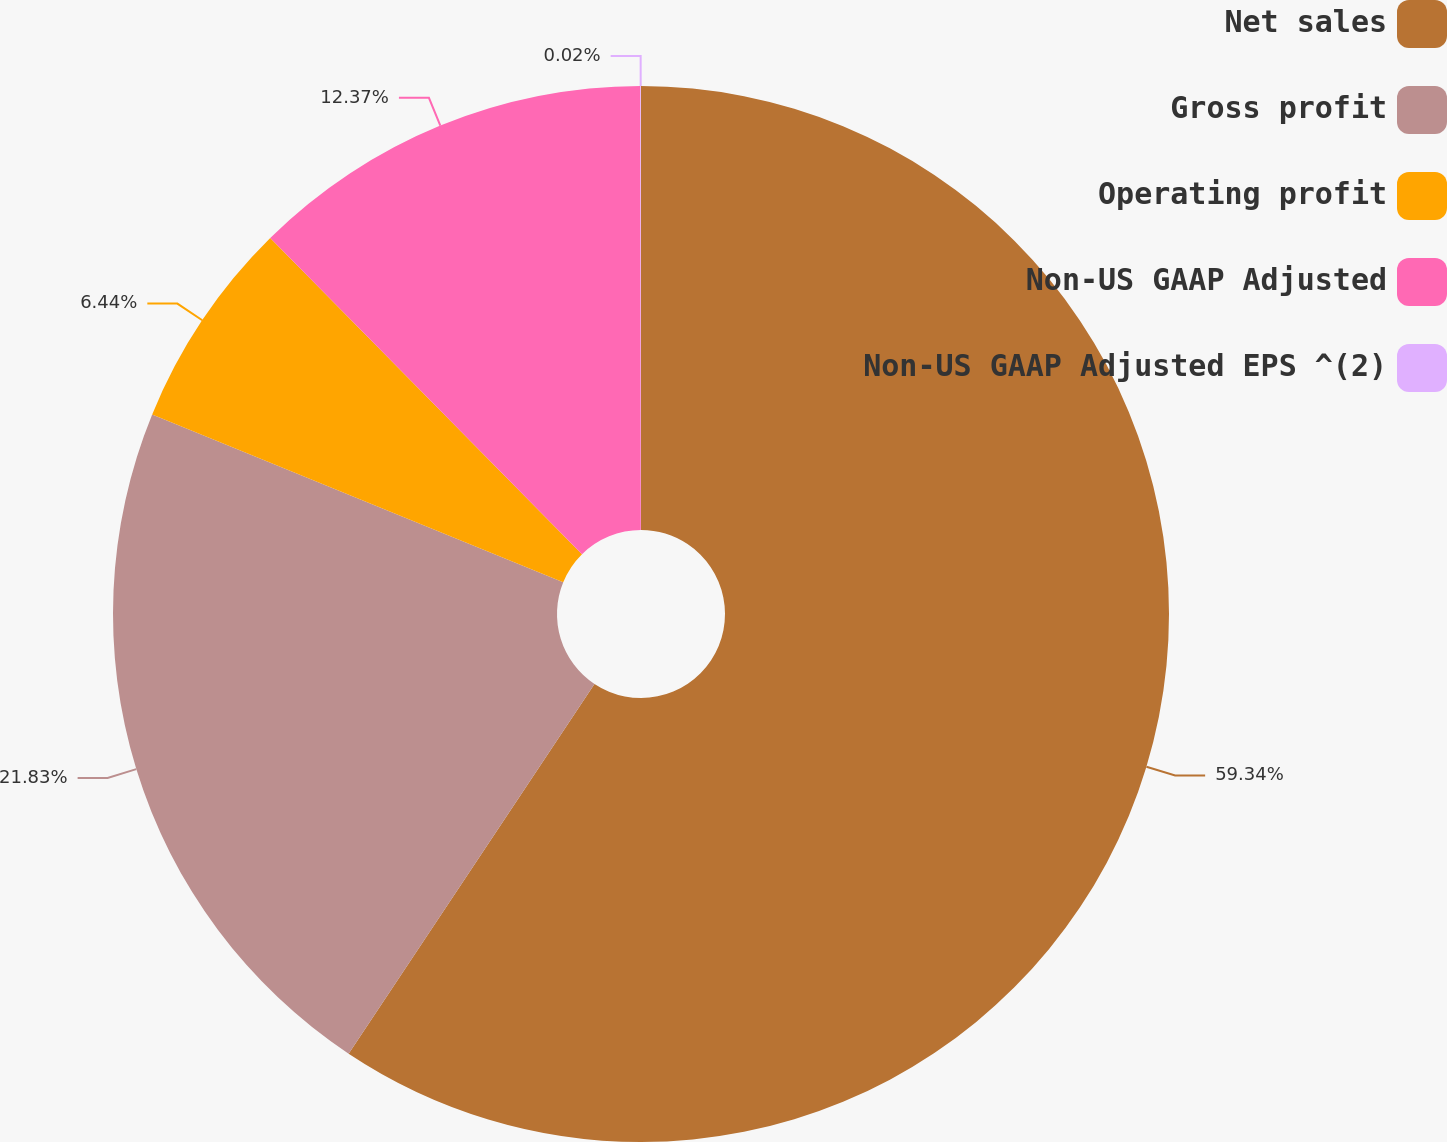Convert chart to OTSL. <chart><loc_0><loc_0><loc_500><loc_500><pie_chart><fcel>Net sales<fcel>Gross profit<fcel>Operating profit<fcel>Non-US GAAP Adjusted<fcel>Non-US GAAP Adjusted EPS ^(2)<nl><fcel>59.34%<fcel>21.83%<fcel>6.44%<fcel>12.37%<fcel>0.02%<nl></chart> 